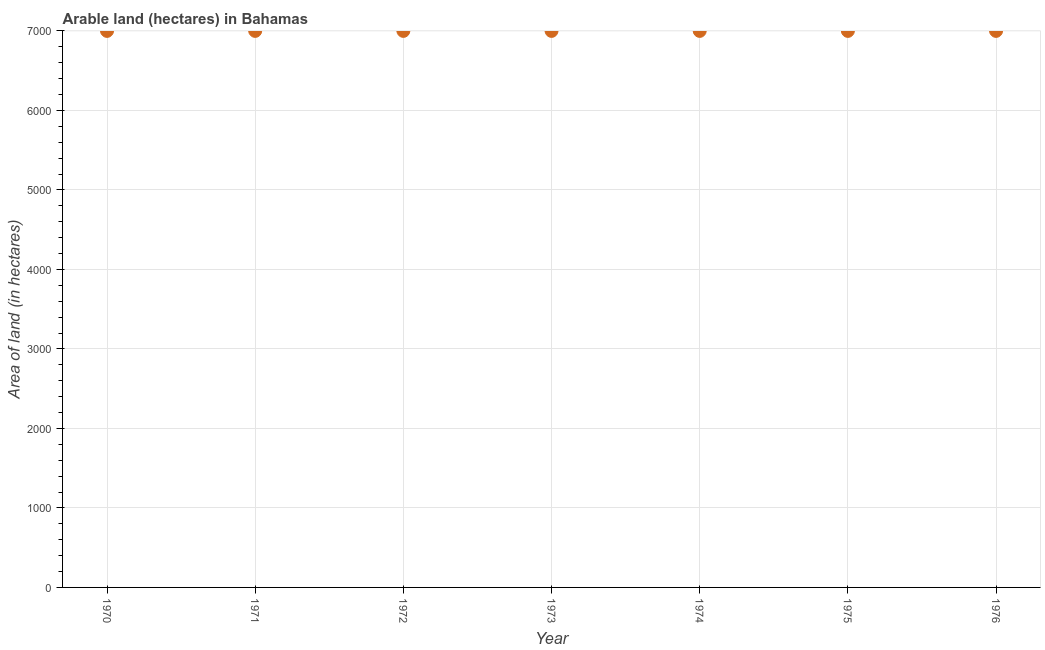What is the area of land in 1972?
Offer a terse response. 7000. Across all years, what is the maximum area of land?
Your answer should be compact. 7000. Across all years, what is the minimum area of land?
Make the answer very short. 7000. What is the sum of the area of land?
Ensure brevity in your answer.  4.90e+04. What is the average area of land per year?
Keep it short and to the point. 7000. What is the median area of land?
Provide a succinct answer. 7000. Do a majority of the years between 1970 and 1974 (inclusive) have area of land greater than 3800 hectares?
Your response must be concise. Yes. Is the difference between the area of land in 1970 and 1971 greater than the difference between any two years?
Provide a short and direct response. Yes. What is the difference between the highest and the second highest area of land?
Give a very brief answer. 0. Is the sum of the area of land in 1971 and 1975 greater than the maximum area of land across all years?
Your answer should be very brief. Yes. What is the difference between the highest and the lowest area of land?
Your answer should be compact. 0. In how many years, is the area of land greater than the average area of land taken over all years?
Provide a succinct answer. 0. How many dotlines are there?
Ensure brevity in your answer.  1. How many years are there in the graph?
Make the answer very short. 7. What is the difference between two consecutive major ticks on the Y-axis?
Keep it short and to the point. 1000. Are the values on the major ticks of Y-axis written in scientific E-notation?
Offer a very short reply. No. Does the graph contain any zero values?
Provide a short and direct response. No. What is the title of the graph?
Keep it short and to the point. Arable land (hectares) in Bahamas. What is the label or title of the Y-axis?
Give a very brief answer. Area of land (in hectares). What is the Area of land (in hectares) in 1970?
Provide a succinct answer. 7000. What is the Area of land (in hectares) in 1971?
Offer a terse response. 7000. What is the Area of land (in hectares) in 1972?
Offer a very short reply. 7000. What is the Area of land (in hectares) in 1973?
Provide a short and direct response. 7000. What is the Area of land (in hectares) in 1974?
Keep it short and to the point. 7000. What is the Area of land (in hectares) in 1975?
Offer a very short reply. 7000. What is the Area of land (in hectares) in 1976?
Keep it short and to the point. 7000. What is the difference between the Area of land (in hectares) in 1970 and 1971?
Your answer should be compact. 0. What is the difference between the Area of land (in hectares) in 1970 and 1973?
Provide a succinct answer. 0. What is the difference between the Area of land (in hectares) in 1970 and 1974?
Offer a very short reply. 0. What is the difference between the Area of land (in hectares) in 1971 and 1972?
Your response must be concise. 0. What is the difference between the Area of land (in hectares) in 1971 and 1973?
Your response must be concise. 0. What is the difference between the Area of land (in hectares) in 1971 and 1975?
Make the answer very short. 0. What is the difference between the Area of land (in hectares) in 1971 and 1976?
Your answer should be compact. 0. What is the difference between the Area of land (in hectares) in 1972 and 1974?
Give a very brief answer. 0. What is the difference between the Area of land (in hectares) in 1972 and 1976?
Your response must be concise. 0. What is the difference between the Area of land (in hectares) in 1973 and 1975?
Ensure brevity in your answer.  0. What is the difference between the Area of land (in hectares) in 1973 and 1976?
Give a very brief answer. 0. What is the difference between the Area of land (in hectares) in 1974 and 1975?
Ensure brevity in your answer.  0. What is the ratio of the Area of land (in hectares) in 1970 to that in 1975?
Your response must be concise. 1. What is the ratio of the Area of land (in hectares) in 1972 to that in 1973?
Provide a succinct answer. 1. What is the ratio of the Area of land (in hectares) in 1972 to that in 1976?
Offer a terse response. 1. What is the ratio of the Area of land (in hectares) in 1974 to that in 1975?
Offer a very short reply. 1. What is the ratio of the Area of land (in hectares) in 1974 to that in 1976?
Offer a terse response. 1. What is the ratio of the Area of land (in hectares) in 1975 to that in 1976?
Provide a short and direct response. 1. 